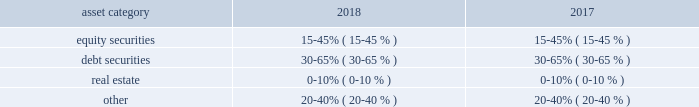2018 ppg annual report and form 10-k 77 u.s .
Qualified pension beginning in 2012 , the company initiated a lump sum payout program that gave certain terminated vested participants in certain u.s .
Defined benefit pension plans the option to take a one-time lump sum cash payment in lieu of receiving a future monthly annuity .
During 2017 , ppg paid $ 87 million in lump sum benefits to terminated vested participants who elected to participate in the program .
As the lump-sum payments were in excess of the expected 2017 service and interest costs for the qualified pension plans , ppg remeasured the periodic benefit obligation of the qualified plans and recorded a settlement charge totaling $ 35 million ( $ 22 million after-tax ) .
U.s .
Non-qualified pension in the first quarter 2017 , ppg made lump-sum payments to certain retirees who had participated in ppg's u.s .
Non-qualified pension plan ( the "nonqualified plan" ) totaling approximately $ 40 million .
As the lump-sum payments were in excess of the expected 2017 service and interest costs for the nonqualified plan , ppg remeasured the periodic benefit obligation of the nonqualified plan as of march 1 , 2017 and recorded a settlement charge totaling $ 22 million ( $ 14 million after-tax ) .
Plan assets each ppg sponsored defined benefit pension plan is managed in accordance with the requirements of local laws and regulations governing defined benefit pension plans for the exclusive purpose of providing pension benefits to participants and their beneficiaries .
Investment committees comprised of ppg managers have fiduciary responsibility to oversee the management of pension plan assets by third party asset managers .
Pension plan assets are held in trust by financial institutions and managed on a day-to-day basis by the asset managers .
The asset managers receive a mandate from each investment committee that is aligned with the asset allocation targets established by each investment committee to achieve the plan 2019s investment strategies .
The performance of the asset managers is monitored and evaluated by the investment committees throughout the year .
Pension plan assets are invested to generate investment earnings over an extended time horizon to help fund the cost of benefits promised under the plans while mitigating investment risk .
The asset allocation targets established for each pension plan are intended to diversify the investments among a variety of asset categories and among a variety of individual securities within each asset category to mitigate investment risk and provide each plan with sufficient liquidity to fund the payment of pension benefits to retirees .
The following summarizes the weighted average target pension plan asset allocation as of december 31 , 2018 and 2017 for all ppg defined benefit plans: .
Notes to the consolidated financial statements .
What was the tax expense for the non-qualified periodic benefit obligation settlement charge? ( $ million )? 
Computations: (22 - 14)
Answer: 8.0. 